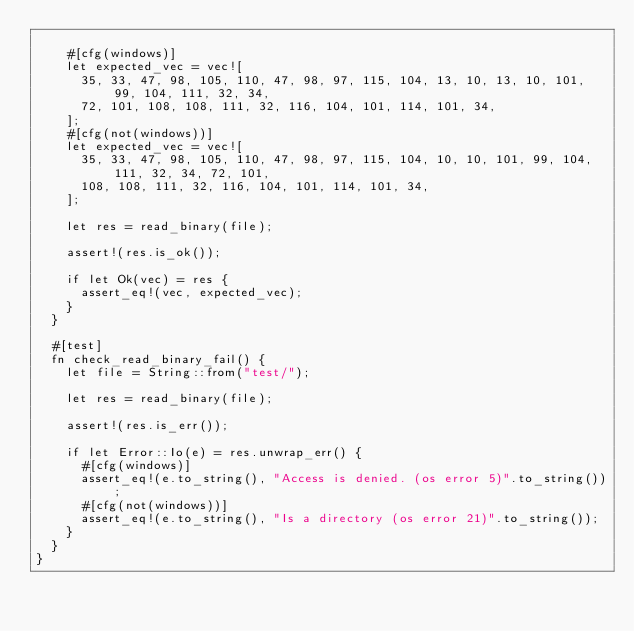Convert code to text. <code><loc_0><loc_0><loc_500><loc_500><_Rust_>
    #[cfg(windows)]
    let expected_vec = vec![
      35, 33, 47, 98, 105, 110, 47, 98, 97, 115, 104, 13, 10, 13, 10, 101, 99, 104, 111, 32, 34,
      72, 101, 108, 108, 111, 32, 116, 104, 101, 114, 101, 34,
    ];
    #[cfg(not(windows))]
    let expected_vec = vec![
      35, 33, 47, 98, 105, 110, 47, 98, 97, 115, 104, 10, 10, 101, 99, 104, 111, 32, 34, 72, 101,
      108, 108, 111, 32, 116, 104, 101, 114, 101, 34,
    ];

    let res = read_binary(file);

    assert!(res.is_ok());

    if let Ok(vec) = res {
      assert_eq!(vec, expected_vec);
    }
  }

  #[test]
  fn check_read_binary_fail() {
    let file = String::from("test/");

    let res = read_binary(file);

    assert!(res.is_err());

    if let Error::Io(e) = res.unwrap_err() {
      #[cfg(windows)]
      assert_eq!(e.to_string(), "Access is denied. (os error 5)".to_string());
      #[cfg(not(windows))]
      assert_eq!(e.to_string(), "Is a directory (os error 21)".to_string());
    }
  }
}
</code> 